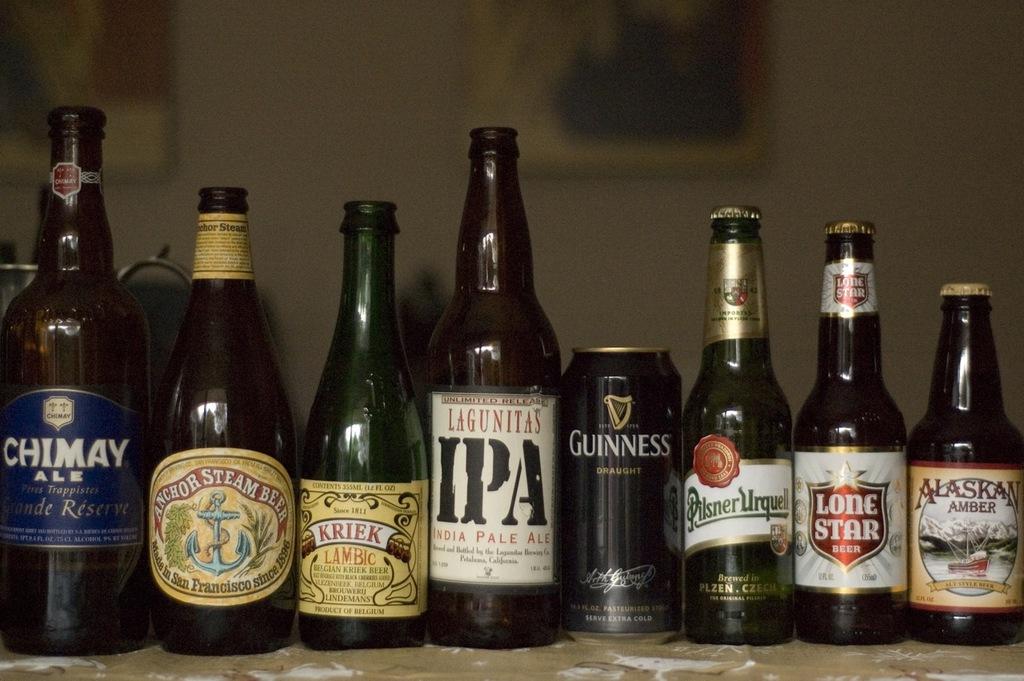What is the name of the canned beer?
Keep it short and to the point. Guinness. 